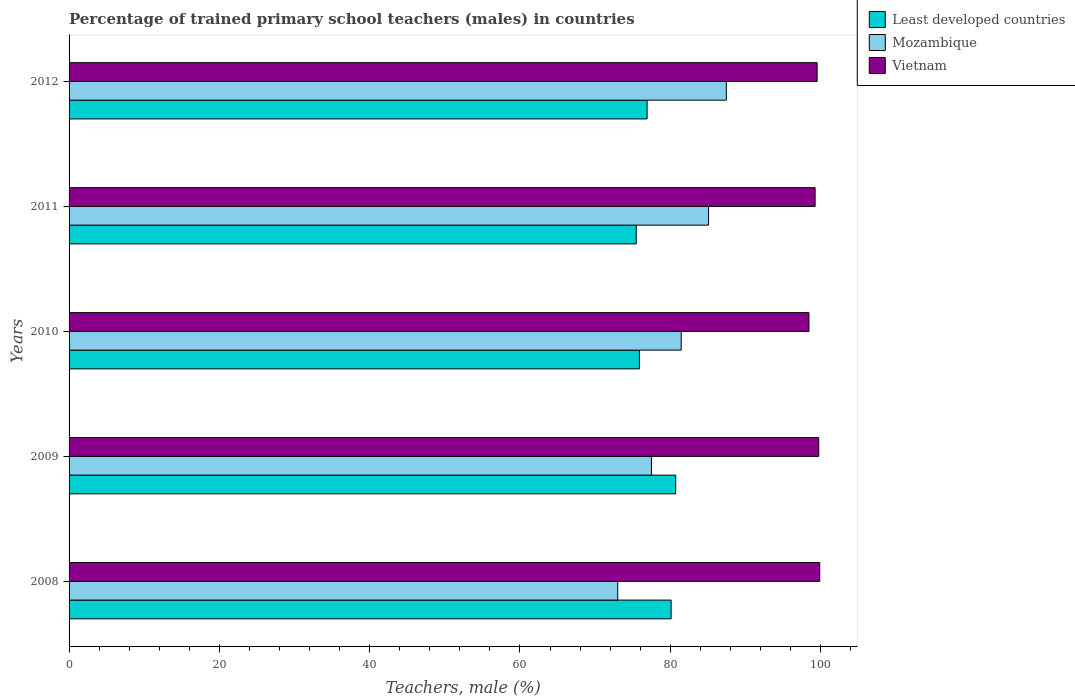How many different coloured bars are there?
Ensure brevity in your answer.  3. In how many cases, is the number of bars for a given year not equal to the number of legend labels?
Offer a very short reply. 0. What is the percentage of trained primary school teachers (males) in Vietnam in 2009?
Your response must be concise. 99.76. Across all years, what is the maximum percentage of trained primary school teachers (males) in Least developed countries?
Give a very brief answer. 80.72. Across all years, what is the minimum percentage of trained primary school teachers (males) in Least developed countries?
Give a very brief answer. 75.48. In which year was the percentage of trained primary school teachers (males) in Vietnam minimum?
Give a very brief answer. 2010. What is the total percentage of trained primary school teachers (males) in Least developed countries in the graph?
Keep it short and to the point. 389.14. What is the difference between the percentage of trained primary school teachers (males) in Mozambique in 2009 and that in 2010?
Provide a succinct answer. -3.96. What is the difference between the percentage of trained primary school teachers (males) in Least developed countries in 2011 and the percentage of trained primary school teachers (males) in Mozambique in 2008?
Make the answer very short. 2.46. What is the average percentage of trained primary school teachers (males) in Least developed countries per year?
Keep it short and to the point. 77.83. In the year 2012, what is the difference between the percentage of trained primary school teachers (males) in Least developed countries and percentage of trained primary school teachers (males) in Mozambique?
Offer a terse response. -10.54. What is the ratio of the percentage of trained primary school teachers (males) in Mozambique in 2009 to that in 2011?
Provide a succinct answer. 0.91. Is the percentage of trained primary school teachers (males) in Mozambique in 2009 less than that in 2011?
Make the answer very short. Yes. Is the difference between the percentage of trained primary school teachers (males) in Least developed countries in 2008 and 2012 greater than the difference between the percentage of trained primary school teachers (males) in Mozambique in 2008 and 2012?
Provide a short and direct response. Yes. What is the difference between the highest and the second highest percentage of trained primary school teachers (males) in Vietnam?
Provide a short and direct response. 0.13. What is the difference between the highest and the lowest percentage of trained primary school teachers (males) in Mozambique?
Make the answer very short. 14.45. In how many years, is the percentage of trained primary school teachers (males) in Mozambique greater than the average percentage of trained primary school teachers (males) in Mozambique taken over all years?
Provide a succinct answer. 3. Is the sum of the percentage of trained primary school teachers (males) in Vietnam in 2008 and 2010 greater than the maximum percentage of trained primary school teachers (males) in Mozambique across all years?
Give a very brief answer. Yes. What does the 1st bar from the top in 2010 represents?
Provide a short and direct response. Vietnam. What does the 3rd bar from the bottom in 2009 represents?
Offer a very short reply. Vietnam. Is it the case that in every year, the sum of the percentage of trained primary school teachers (males) in Vietnam and percentage of trained primary school teachers (males) in Least developed countries is greater than the percentage of trained primary school teachers (males) in Mozambique?
Ensure brevity in your answer.  Yes. How many bars are there?
Offer a very short reply. 15. Are all the bars in the graph horizontal?
Provide a succinct answer. Yes. What is the difference between two consecutive major ticks on the X-axis?
Give a very brief answer. 20. Are the values on the major ticks of X-axis written in scientific E-notation?
Offer a terse response. No. Where does the legend appear in the graph?
Give a very brief answer. Top right. What is the title of the graph?
Ensure brevity in your answer.  Percentage of trained primary school teachers (males) in countries. What is the label or title of the X-axis?
Offer a terse response. Teachers, male (%). What is the label or title of the Y-axis?
Ensure brevity in your answer.  Years. What is the Teachers, male (%) of Least developed countries in 2008?
Provide a succinct answer. 80.12. What is the Teachers, male (%) of Mozambique in 2008?
Your response must be concise. 73.01. What is the Teachers, male (%) in Vietnam in 2008?
Make the answer very short. 99.89. What is the Teachers, male (%) of Least developed countries in 2009?
Provide a short and direct response. 80.72. What is the Teachers, male (%) in Mozambique in 2009?
Your answer should be very brief. 77.5. What is the Teachers, male (%) of Vietnam in 2009?
Keep it short and to the point. 99.76. What is the Teachers, male (%) of Least developed countries in 2010?
Ensure brevity in your answer.  75.9. What is the Teachers, male (%) in Mozambique in 2010?
Your answer should be very brief. 81.46. What is the Teachers, male (%) of Vietnam in 2010?
Your answer should be compact. 98.46. What is the Teachers, male (%) in Least developed countries in 2011?
Ensure brevity in your answer.  75.48. What is the Teachers, male (%) of Mozambique in 2011?
Your answer should be compact. 85.1. What is the Teachers, male (%) of Vietnam in 2011?
Your response must be concise. 99.28. What is the Teachers, male (%) in Least developed countries in 2012?
Your answer should be very brief. 76.92. What is the Teachers, male (%) in Mozambique in 2012?
Your response must be concise. 87.46. What is the Teachers, male (%) in Vietnam in 2012?
Make the answer very short. 99.55. Across all years, what is the maximum Teachers, male (%) of Least developed countries?
Keep it short and to the point. 80.72. Across all years, what is the maximum Teachers, male (%) in Mozambique?
Your answer should be compact. 87.46. Across all years, what is the maximum Teachers, male (%) of Vietnam?
Ensure brevity in your answer.  99.89. Across all years, what is the minimum Teachers, male (%) in Least developed countries?
Ensure brevity in your answer.  75.48. Across all years, what is the minimum Teachers, male (%) of Mozambique?
Ensure brevity in your answer.  73.01. Across all years, what is the minimum Teachers, male (%) of Vietnam?
Your answer should be compact. 98.46. What is the total Teachers, male (%) in Least developed countries in the graph?
Offer a very short reply. 389.14. What is the total Teachers, male (%) in Mozambique in the graph?
Your answer should be compact. 404.53. What is the total Teachers, male (%) in Vietnam in the graph?
Your answer should be compact. 496.94. What is the difference between the Teachers, male (%) in Least developed countries in 2008 and that in 2009?
Offer a terse response. -0.61. What is the difference between the Teachers, male (%) of Mozambique in 2008 and that in 2009?
Your response must be concise. -4.48. What is the difference between the Teachers, male (%) in Vietnam in 2008 and that in 2009?
Offer a very short reply. 0.13. What is the difference between the Teachers, male (%) in Least developed countries in 2008 and that in 2010?
Provide a short and direct response. 4.22. What is the difference between the Teachers, male (%) in Mozambique in 2008 and that in 2010?
Provide a succinct answer. -8.44. What is the difference between the Teachers, male (%) in Vietnam in 2008 and that in 2010?
Provide a short and direct response. 1.44. What is the difference between the Teachers, male (%) of Least developed countries in 2008 and that in 2011?
Make the answer very short. 4.64. What is the difference between the Teachers, male (%) in Mozambique in 2008 and that in 2011?
Provide a short and direct response. -12.08. What is the difference between the Teachers, male (%) of Vietnam in 2008 and that in 2011?
Keep it short and to the point. 0.62. What is the difference between the Teachers, male (%) of Least developed countries in 2008 and that in 2012?
Provide a short and direct response. 3.19. What is the difference between the Teachers, male (%) of Mozambique in 2008 and that in 2012?
Offer a very short reply. -14.45. What is the difference between the Teachers, male (%) of Vietnam in 2008 and that in 2012?
Provide a short and direct response. 0.35. What is the difference between the Teachers, male (%) in Least developed countries in 2009 and that in 2010?
Your answer should be very brief. 4.83. What is the difference between the Teachers, male (%) in Mozambique in 2009 and that in 2010?
Offer a terse response. -3.96. What is the difference between the Teachers, male (%) of Vietnam in 2009 and that in 2010?
Provide a short and direct response. 1.3. What is the difference between the Teachers, male (%) in Least developed countries in 2009 and that in 2011?
Ensure brevity in your answer.  5.25. What is the difference between the Teachers, male (%) in Mozambique in 2009 and that in 2011?
Offer a terse response. -7.6. What is the difference between the Teachers, male (%) in Vietnam in 2009 and that in 2011?
Your response must be concise. 0.49. What is the difference between the Teachers, male (%) in Least developed countries in 2009 and that in 2012?
Your response must be concise. 3.8. What is the difference between the Teachers, male (%) in Mozambique in 2009 and that in 2012?
Provide a succinct answer. -9.97. What is the difference between the Teachers, male (%) in Vietnam in 2009 and that in 2012?
Provide a short and direct response. 0.22. What is the difference between the Teachers, male (%) of Least developed countries in 2010 and that in 2011?
Your response must be concise. 0.42. What is the difference between the Teachers, male (%) of Mozambique in 2010 and that in 2011?
Provide a short and direct response. -3.64. What is the difference between the Teachers, male (%) in Vietnam in 2010 and that in 2011?
Make the answer very short. -0.82. What is the difference between the Teachers, male (%) of Least developed countries in 2010 and that in 2012?
Offer a terse response. -1.02. What is the difference between the Teachers, male (%) in Mozambique in 2010 and that in 2012?
Make the answer very short. -6. What is the difference between the Teachers, male (%) in Vietnam in 2010 and that in 2012?
Offer a terse response. -1.09. What is the difference between the Teachers, male (%) in Least developed countries in 2011 and that in 2012?
Make the answer very short. -1.45. What is the difference between the Teachers, male (%) in Mozambique in 2011 and that in 2012?
Your response must be concise. -2.36. What is the difference between the Teachers, male (%) in Vietnam in 2011 and that in 2012?
Your answer should be very brief. -0.27. What is the difference between the Teachers, male (%) of Least developed countries in 2008 and the Teachers, male (%) of Mozambique in 2009?
Make the answer very short. 2.62. What is the difference between the Teachers, male (%) in Least developed countries in 2008 and the Teachers, male (%) in Vietnam in 2009?
Offer a terse response. -19.65. What is the difference between the Teachers, male (%) of Mozambique in 2008 and the Teachers, male (%) of Vietnam in 2009?
Your answer should be very brief. -26.75. What is the difference between the Teachers, male (%) in Least developed countries in 2008 and the Teachers, male (%) in Mozambique in 2010?
Your answer should be very brief. -1.34. What is the difference between the Teachers, male (%) of Least developed countries in 2008 and the Teachers, male (%) of Vietnam in 2010?
Your answer should be very brief. -18.34. What is the difference between the Teachers, male (%) of Mozambique in 2008 and the Teachers, male (%) of Vietnam in 2010?
Provide a short and direct response. -25.44. What is the difference between the Teachers, male (%) of Least developed countries in 2008 and the Teachers, male (%) of Mozambique in 2011?
Provide a short and direct response. -4.98. What is the difference between the Teachers, male (%) in Least developed countries in 2008 and the Teachers, male (%) in Vietnam in 2011?
Give a very brief answer. -19.16. What is the difference between the Teachers, male (%) in Mozambique in 2008 and the Teachers, male (%) in Vietnam in 2011?
Your response must be concise. -26.26. What is the difference between the Teachers, male (%) of Least developed countries in 2008 and the Teachers, male (%) of Mozambique in 2012?
Ensure brevity in your answer.  -7.35. What is the difference between the Teachers, male (%) of Least developed countries in 2008 and the Teachers, male (%) of Vietnam in 2012?
Ensure brevity in your answer.  -19.43. What is the difference between the Teachers, male (%) of Mozambique in 2008 and the Teachers, male (%) of Vietnam in 2012?
Your answer should be very brief. -26.53. What is the difference between the Teachers, male (%) in Least developed countries in 2009 and the Teachers, male (%) in Mozambique in 2010?
Ensure brevity in your answer.  -0.74. What is the difference between the Teachers, male (%) in Least developed countries in 2009 and the Teachers, male (%) in Vietnam in 2010?
Your response must be concise. -17.74. What is the difference between the Teachers, male (%) of Mozambique in 2009 and the Teachers, male (%) of Vietnam in 2010?
Offer a terse response. -20.96. What is the difference between the Teachers, male (%) of Least developed countries in 2009 and the Teachers, male (%) of Mozambique in 2011?
Your answer should be very brief. -4.38. What is the difference between the Teachers, male (%) of Least developed countries in 2009 and the Teachers, male (%) of Vietnam in 2011?
Offer a terse response. -18.55. What is the difference between the Teachers, male (%) of Mozambique in 2009 and the Teachers, male (%) of Vietnam in 2011?
Your answer should be very brief. -21.78. What is the difference between the Teachers, male (%) in Least developed countries in 2009 and the Teachers, male (%) in Mozambique in 2012?
Offer a very short reply. -6.74. What is the difference between the Teachers, male (%) of Least developed countries in 2009 and the Teachers, male (%) of Vietnam in 2012?
Ensure brevity in your answer.  -18.82. What is the difference between the Teachers, male (%) in Mozambique in 2009 and the Teachers, male (%) in Vietnam in 2012?
Offer a terse response. -22.05. What is the difference between the Teachers, male (%) of Least developed countries in 2010 and the Teachers, male (%) of Mozambique in 2011?
Offer a terse response. -9.2. What is the difference between the Teachers, male (%) in Least developed countries in 2010 and the Teachers, male (%) in Vietnam in 2011?
Keep it short and to the point. -23.38. What is the difference between the Teachers, male (%) of Mozambique in 2010 and the Teachers, male (%) of Vietnam in 2011?
Your answer should be compact. -17.82. What is the difference between the Teachers, male (%) of Least developed countries in 2010 and the Teachers, male (%) of Mozambique in 2012?
Provide a short and direct response. -11.57. What is the difference between the Teachers, male (%) in Least developed countries in 2010 and the Teachers, male (%) in Vietnam in 2012?
Provide a short and direct response. -23.65. What is the difference between the Teachers, male (%) in Mozambique in 2010 and the Teachers, male (%) in Vietnam in 2012?
Your answer should be very brief. -18.09. What is the difference between the Teachers, male (%) of Least developed countries in 2011 and the Teachers, male (%) of Mozambique in 2012?
Provide a short and direct response. -11.99. What is the difference between the Teachers, male (%) of Least developed countries in 2011 and the Teachers, male (%) of Vietnam in 2012?
Your response must be concise. -24.07. What is the difference between the Teachers, male (%) in Mozambique in 2011 and the Teachers, male (%) in Vietnam in 2012?
Provide a short and direct response. -14.45. What is the average Teachers, male (%) of Least developed countries per year?
Your answer should be very brief. 77.83. What is the average Teachers, male (%) in Mozambique per year?
Give a very brief answer. 80.91. What is the average Teachers, male (%) of Vietnam per year?
Provide a succinct answer. 99.39. In the year 2008, what is the difference between the Teachers, male (%) of Least developed countries and Teachers, male (%) of Mozambique?
Make the answer very short. 7.1. In the year 2008, what is the difference between the Teachers, male (%) in Least developed countries and Teachers, male (%) in Vietnam?
Your answer should be compact. -19.78. In the year 2008, what is the difference between the Teachers, male (%) of Mozambique and Teachers, male (%) of Vietnam?
Offer a very short reply. -26.88. In the year 2009, what is the difference between the Teachers, male (%) in Least developed countries and Teachers, male (%) in Mozambique?
Your answer should be very brief. 3.23. In the year 2009, what is the difference between the Teachers, male (%) of Least developed countries and Teachers, male (%) of Vietnam?
Offer a terse response. -19.04. In the year 2009, what is the difference between the Teachers, male (%) in Mozambique and Teachers, male (%) in Vietnam?
Your answer should be very brief. -22.27. In the year 2010, what is the difference between the Teachers, male (%) of Least developed countries and Teachers, male (%) of Mozambique?
Your answer should be compact. -5.56. In the year 2010, what is the difference between the Teachers, male (%) in Least developed countries and Teachers, male (%) in Vietnam?
Offer a very short reply. -22.56. In the year 2010, what is the difference between the Teachers, male (%) in Mozambique and Teachers, male (%) in Vietnam?
Make the answer very short. -17. In the year 2011, what is the difference between the Teachers, male (%) in Least developed countries and Teachers, male (%) in Mozambique?
Offer a terse response. -9.62. In the year 2011, what is the difference between the Teachers, male (%) of Least developed countries and Teachers, male (%) of Vietnam?
Your answer should be very brief. -23.8. In the year 2011, what is the difference between the Teachers, male (%) in Mozambique and Teachers, male (%) in Vietnam?
Make the answer very short. -14.18. In the year 2012, what is the difference between the Teachers, male (%) of Least developed countries and Teachers, male (%) of Mozambique?
Offer a very short reply. -10.54. In the year 2012, what is the difference between the Teachers, male (%) of Least developed countries and Teachers, male (%) of Vietnam?
Provide a succinct answer. -22.62. In the year 2012, what is the difference between the Teachers, male (%) in Mozambique and Teachers, male (%) in Vietnam?
Offer a terse response. -12.08. What is the ratio of the Teachers, male (%) in Least developed countries in 2008 to that in 2009?
Your answer should be very brief. 0.99. What is the ratio of the Teachers, male (%) in Mozambique in 2008 to that in 2009?
Keep it short and to the point. 0.94. What is the ratio of the Teachers, male (%) of Least developed countries in 2008 to that in 2010?
Offer a very short reply. 1.06. What is the ratio of the Teachers, male (%) of Mozambique in 2008 to that in 2010?
Offer a very short reply. 0.9. What is the ratio of the Teachers, male (%) of Vietnam in 2008 to that in 2010?
Your response must be concise. 1.01. What is the ratio of the Teachers, male (%) of Least developed countries in 2008 to that in 2011?
Your answer should be very brief. 1.06. What is the ratio of the Teachers, male (%) in Mozambique in 2008 to that in 2011?
Give a very brief answer. 0.86. What is the ratio of the Teachers, male (%) in Least developed countries in 2008 to that in 2012?
Make the answer very short. 1.04. What is the ratio of the Teachers, male (%) of Mozambique in 2008 to that in 2012?
Keep it short and to the point. 0.83. What is the ratio of the Teachers, male (%) in Vietnam in 2008 to that in 2012?
Ensure brevity in your answer.  1. What is the ratio of the Teachers, male (%) in Least developed countries in 2009 to that in 2010?
Keep it short and to the point. 1.06. What is the ratio of the Teachers, male (%) of Mozambique in 2009 to that in 2010?
Offer a very short reply. 0.95. What is the ratio of the Teachers, male (%) of Vietnam in 2009 to that in 2010?
Ensure brevity in your answer.  1.01. What is the ratio of the Teachers, male (%) in Least developed countries in 2009 to that in 2011?
Ensure brevity in your answer.  1.07. What is the ratio of the Teachers, male (%) in Mozambique in 2009 to that in 2011?
Ensure brevity in your answer.  0.91. What is the ratio of the Teachers, male (%) in Vietnam in 2009 to that in 2011?
Give a very brief answer. 1. What is the ratio of the Teachers, male (%) of Least developed countries in 2009 to that in 2012?
Make the answer very short. 1.05. What is the ratio of the Teachers, male (%) of Mozambique in 2009 to that in 2012?
Keep it short and to the point. 0.89. What is the ratio of the Teachers, male (%) of Least developed countries in 2010 to that in 2011?
Offer a terse response. 1.01. What is the ratio of the Teachers, male (%) in Mozambique in 2010 to that in 2011?
Provide a short and direct response. 0.96. What is the ratio of the Teachers, male (%) of Vietnam in 2010 to that in 2011?
Make the answer very short. 0.99. What is the ratio of the Teachers, male (%) in Least developed countries in 2010 to that in 2012?
Your response must be concise. 0.99. What is the ratio of the Teachers, male (%) in Mozambique in 2010 to that in 2012?
Your answer should be very brief. 0.93. What is the ratio of the Teachers, male (%) in Least developed countries in 2011 to that in 2012?
Provide a short and direct response. 0.98. What is the ratio of the Teachers, male (%) of Vietnam in 2011 to that in 2012?
Your response must be concise. 1. What is the difference between the highest and the second highest Teachers, male (%) of Least developed countries?
Your answer should be compact. 0.61. What is the difference between the highest and the second highest Teachers, male (%) of Mozambique?
Your answer should be compact. 2.36. What is the difference between the highest and the second highest Teachers, male (%) in Vietnam?
Ensure brevity in your answer.  0.13. What is the difference between the highest and the lowest Teachers, male (%) of Least developed countries?
Provide a short and direct response. 5.25. What is the difference between the highest and the lowest Teachers, male (%) in Mozambique?
Provide a succinct answer. 14.45. What is the difference between the highest and the lowest Teachers, male (%) of Vietnam?
Give a very brief answer. 1.44. 